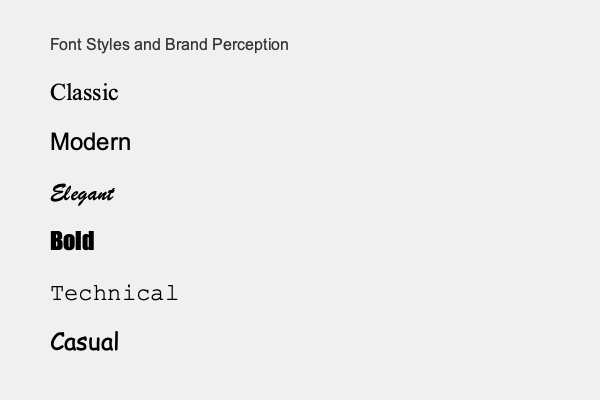Which font style would be most appropriate for a luxury jewelry brand aiming to convey elegance and sophistication in their visual branding? To answer this question, we need to consider the connotations and perceptions associated with different font styles:

1. Classic (Times New Roman): Traditional, formal, and authoritative.
2. Modern (Arial): Clean, contemporary, and neutral.
3. Elegant (Brush Script MT): Sophisticated, luxurious, and refined.
4. Bold (Impact): Strong, attention-grabbing, and assertive.
5. Technical (Courier New): Precise, structured, and functional.
6. Casual (Comic Sans MS): Informal, friendly, and approachable.

For a luxury jewelry brand aiming to convey elegance and sophistication:

1. The brand needs to project a high-end, refined image.
2. Elegance and sophistication are key attributes for luxury jewelry.
3. The font should reflect the premium nature of the products.
4. It should evoke a sense of timelessness and class.

Among the given options, the Elegant (Brush Script MT) font style best aligns with these requirements. It conveys sophistication, luxury, and refinement, which are ideal for a high-end jewelry brand's visual branding.
Answer: Elegant (Brush Script MT) 